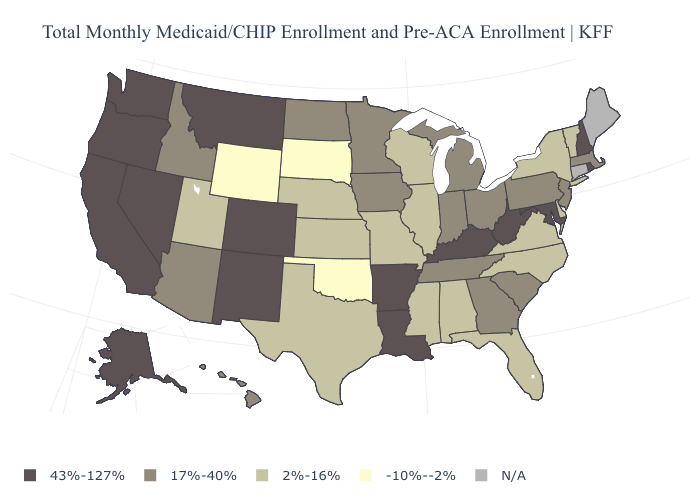Does Oregon have the highest value in the West?
Write a very short answer. Yes. Name the states that have a value in the range 43%-127%?
Short answer required. Alaska, Arkansas, California, Colorado, Kentucky, Louisiana, Maryland, Montana, Nevada, New Hampshire, New Mexico, Oregon, Rhode Island, Washington, West Virginia. What is the value of Mississippi?
Write a very short answer. 2%-16%. What is the value of Maryland?
Be succinct. 43%-127%. Among the states that border Kansas , which have the highest value?
Concise answer only. Colorado. What is the value of Mississippi?
Keep it brief. 2%-16%. Among the states that border California , which have the highest value?
Be succinct. Nevada, Oregon. What is the value of Connecticut?
Be succinct. N/A. Name the states that have a value in the range N/A?
Quick response, please. Connecticut, Maine. What is the value of Hawaii?
Concise answer only. 17%-40%. Which states have the lowest value in the West?
Quick response, please. Wyoming. Name the states that have a value in the range N/A?
Answer briefly. Connecticut, Maine. Among the states that border Wisconsin , which have the lowest value?
Short answer required. Illinois. 